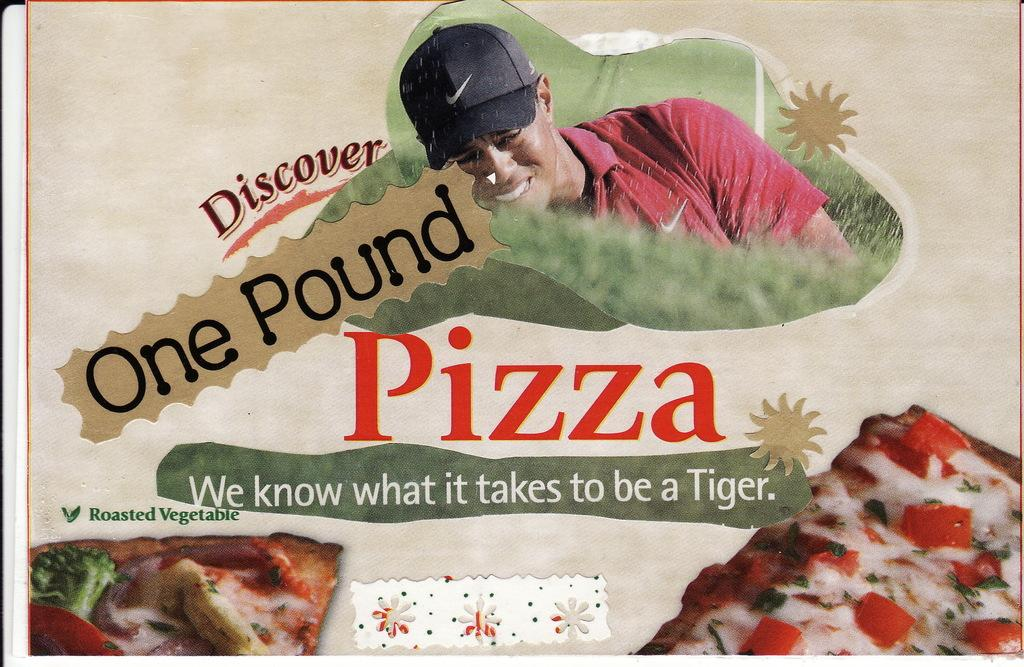What is featured on the poster in the image? The poster contains a picture of a person and a pizza. What else can be found on the poster besides the images? There is text on the poster. What does the person's brother do with the pizza in the image? There is no person's brother or pizza-related action depicted in the image; it only features a poster with a picture of a person and a pizza. 